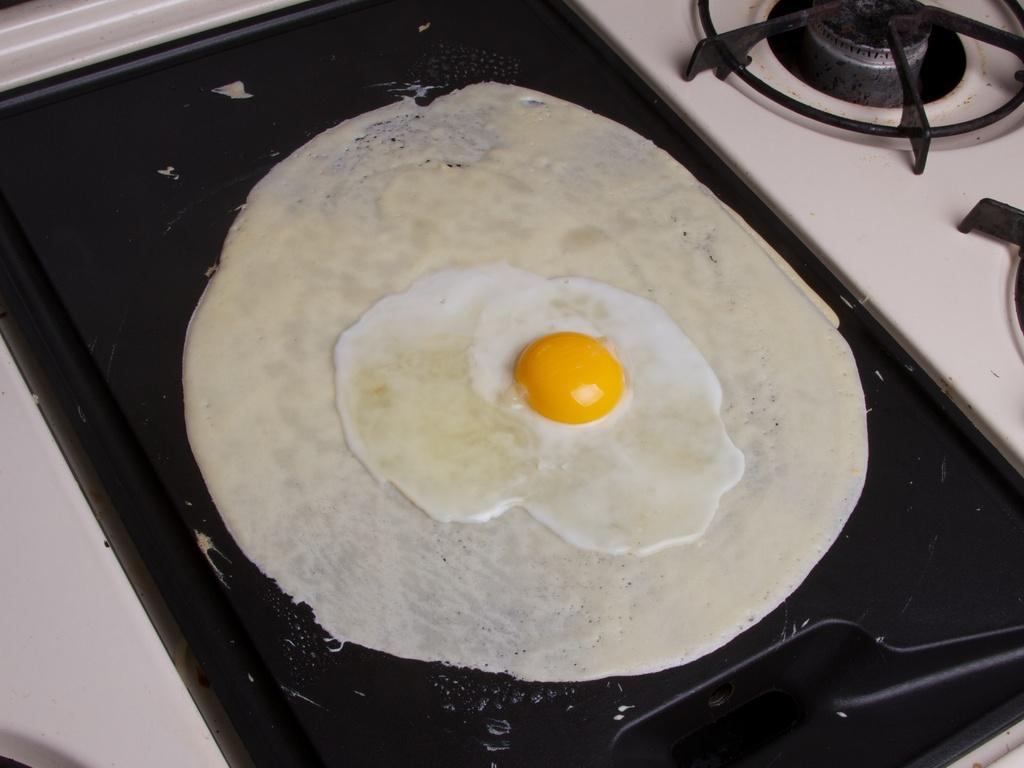What is the main subject of the image? There is a food item in the image. Where is the food item located? The food item is on a surface. What other object can be seen in the image? There is a gas stove in the image. What type of berry is being driven in the image? There is no berry or driving activity present in the image. 